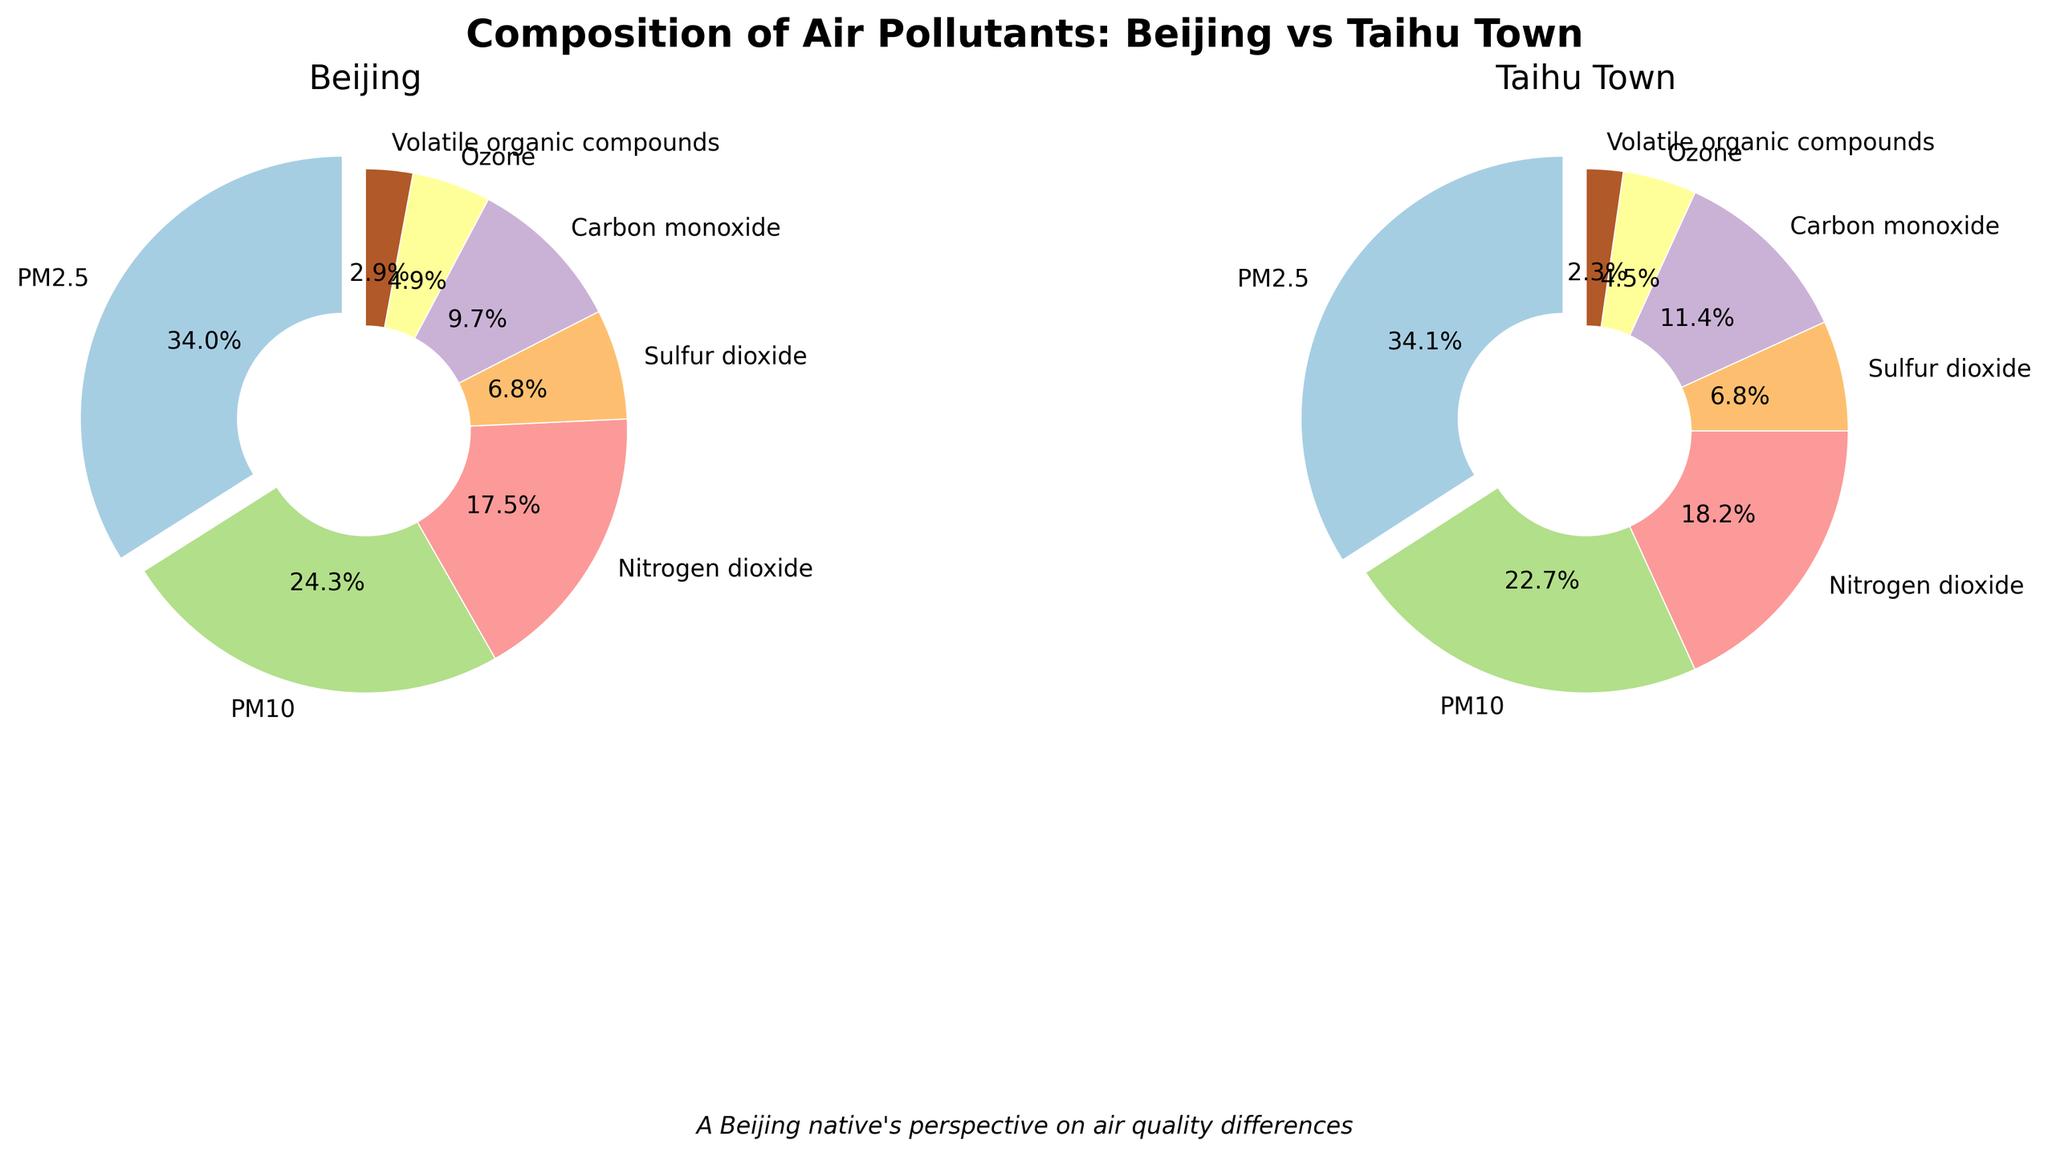What is the percentage of PM2.5 in Beijing compared to Taihu Town? To answer this question, look at the legend or labels of the pie charts. In Beijing, PM2.5 is 35%, while in Taihu Town, it is 15%.
Answer: Beijing: 35%, Taihu Town: 15% Which pollutant has the highest percentage in both Beijing and Taihu Town? In the charts, identify the segment with the largest value in both pie charts. For Beijing, it's PM2.5 at 35%. For Taihu Town, it's also PM2.5 at 15%.
Answer: PM2.5 What is the difference in the percentage of Carbon monoxide between Beijing and Taihu Town? Find Carbon monoxide (CO) in both charts. In Beijing, it's 10%, and in Taihu Town, it's 5%. Subtract 5% from 10% to find the difference.
Answer: 5% Total up the percentage of PM2.5, PM10, and Volatile organic compounds in Taihu Town. Sum the percentages for these pollutants from the Taihu Town chart: PM2.5 (15%) + PM10 (10%) + Volatile organic compounds (1%) = 26%
Answer: 26% Which location has a higher percentage of Nitrogen dioxide? Compare the Nitrogen dioxide percentages in both charts. In Beijing, it is 18%, and in Taihu Town, it is 8%.
Answer: Beijing Which pollutant has the smallest percentage in Beijing's pie chart? Look for the smallest segment in Beijing's pie chart. The smallest percentage is Volatile organic compounds at 3%.
Answer: Volatile organic compounds Does any pollutant share the same percentage in both Beijing and Taihu Town? Compare the percentages of each pollutant side-by-side in the charts, none of the pollutants have the same percentage in both cities.
Answer: No Calculate the combined percentage of Sulfur dioxide and Ozone in Taihu Town. Add the percentages of Sulfur dioxide (3%) and Ozone (2%) in Taihu Town. The combined percentage is 3% + 2% = 5%.
Answer: 5% Identify all pollutants that have a higher percentage in Taihu Town compared to Beijing. Compare each pollutant's percentages in both charts. None of the pollutants have a higher percentage in Taihu Town compared to Beijing.
Answer: None How does the wedge size of PM2.5 in Beijing compare to that in Taihu Town? Visually, the PM2.5 wedge in Beijing's pie chart is much larger than the PM2.5 wedge in Taihu Town's pie chart, indicating a higher percentage.
Answer: Larger in Beijing 